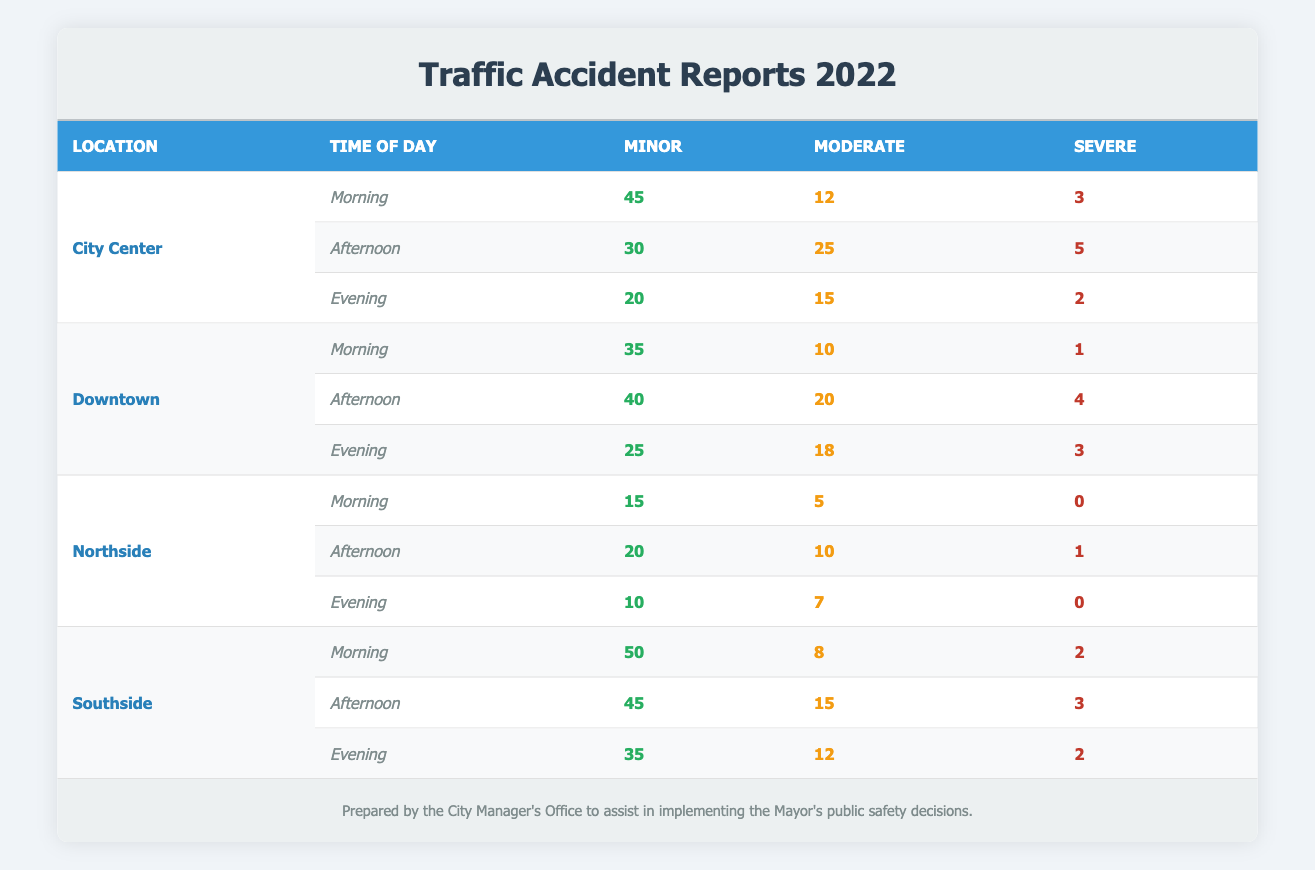What is the total number of traffic accidents reported in the City Center in the afternoon? To find the total number of traffic accidents in the City Center during the afternoon, we sum the values of all severity categories: Minor (30) + Moderate (25) + Severe (5) = 60.
Answer: 60 Which location had the highest number of severe accidents reported in the morning? By looking at the morning data, we see City Center reported 3 severe accidents, Downtown reported 1 severe accident, Northside reported 0, and Southside also reported 2. City Center has the highest number of severe accidents in the morning.
Answer: City Center What is the difference in the number of minor accidents between Southside and Northside in the evening? For Southside, the number of minor accidents in the evening is 35, and for Northside, it is 10. The difference is calculated as 35 - 10 = 25.
Answer: 25 Was the number of moderate accidents reported during the afternoon in Southside greater than in Downtown? For Southside in the afternoon, there were 15 moderate accidents, while for Downtown, there were 20 moderate accidents. Since 15 is not greater than 20, the statement is false.
Answer: No What is the average number of moderate accidents across all locations in the evening? The number of moderate accidents for evening are: City Center (15), Downtown (18), Northside (7), and Southside (12). To find the average, sum them up: 15 + 18 + 7 + 12 = 52. There are 4 data points, so the average is 52 / 4 = 13.
Answer: 13 Which time of day had the highest total number of minor accidents across all locations? Calculating the total minor accidents for each time of day: Morning (45 + 35 + 15 + 50 = 145), Afternoon (30 + 40 + 20 + 45 = 135), Evening (20 + 25 + 10 + 35 = 90). The highest is Morning with 145 minor accidents.
Answer: Morning Are there more moderate accidents in the afternoon compared to the morning in Downtown? In the afternoon, Downtown had 20 moderate accidents, while in the morning it had 10. Since 20 is greater than 10, the statement is true.
Answer: Yes 